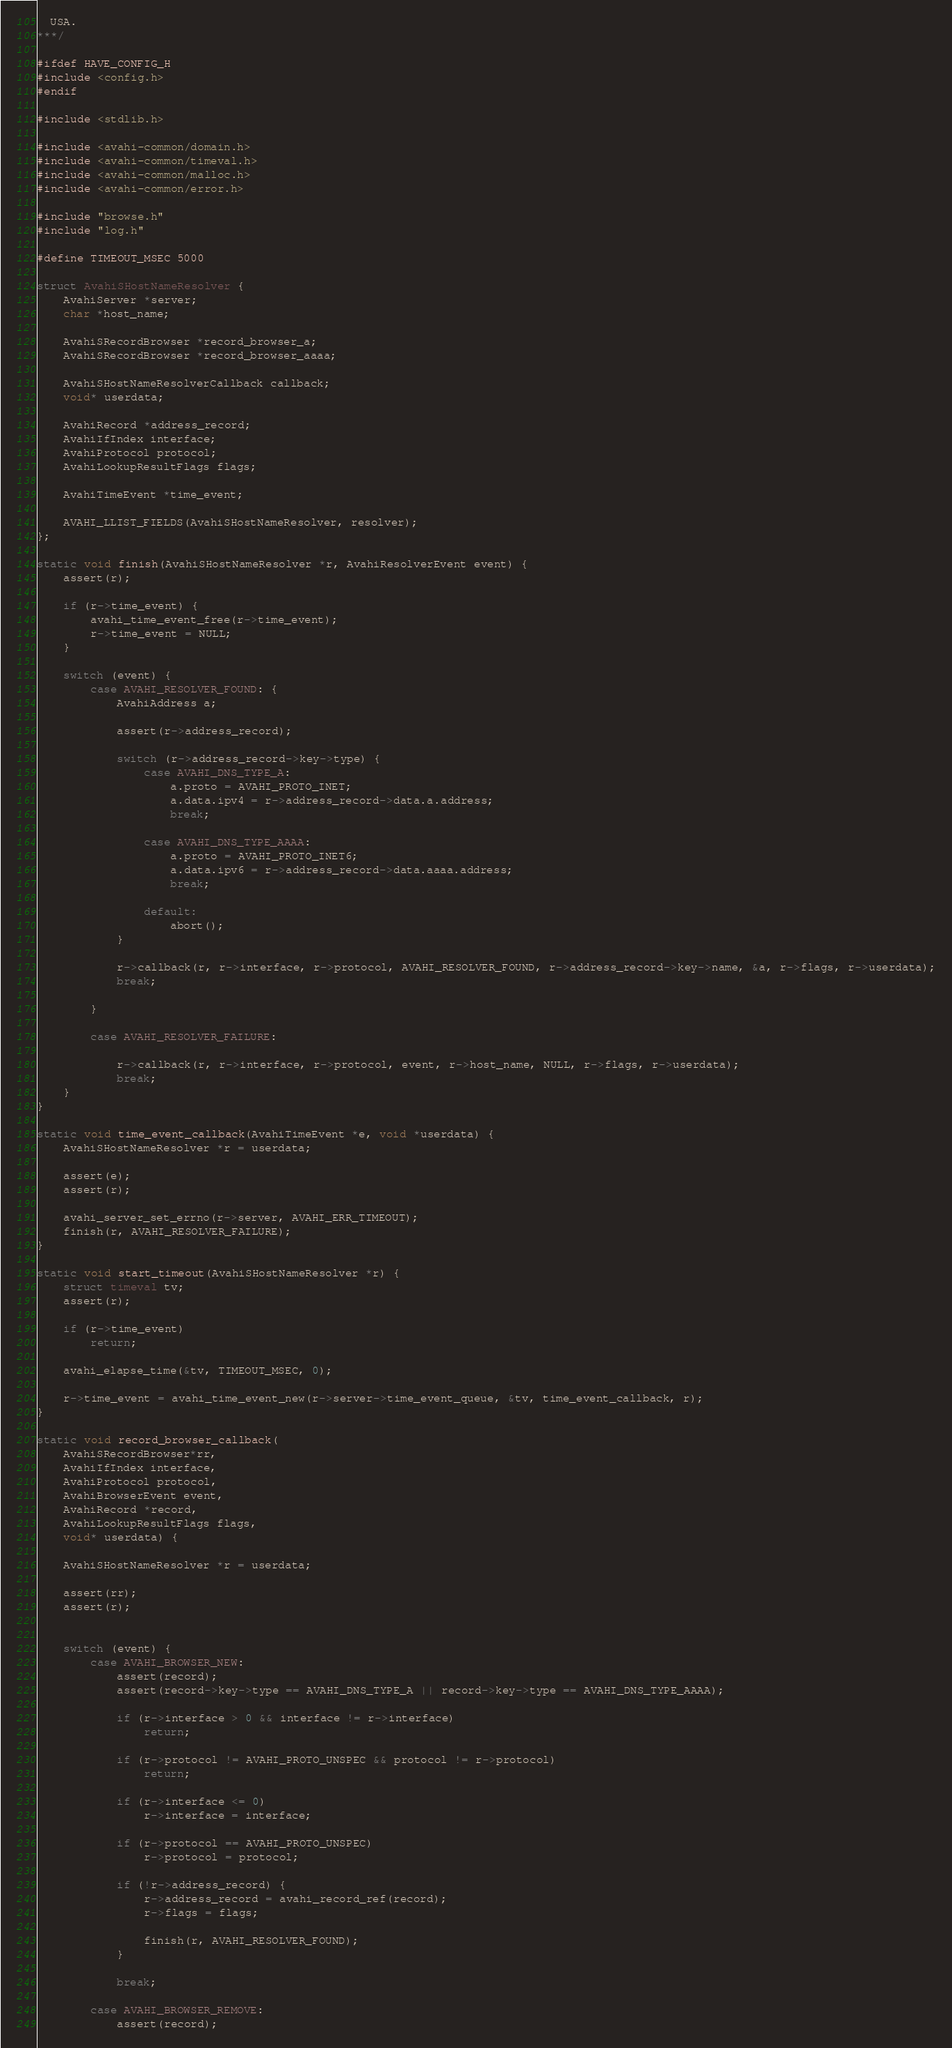<code> <loc_0><loc_0><loc_500><loc_500><_C_>  USA.
***/

#ifdef HAVE_CONFIG_H
#include <config.h>
#endif

#include <stdlib.h>

#include <avahi-common/domain.h>
#include <avahi-common/timeval.h>
#include <avahi-common/malloc.h>
#include <avahi-common/error.h>

#include "browse.h"
#include "log.h"

#define TIMEOUT_MSEC 5000

struct AvahiSHostNameResolver {
    AvahiServer *server;
    char *host_name;

    AvahiSRecordBrowser *record_browser_a;
    AvahiSRecordBrowser *record_browser_aaaa;

    AvahiSHostNameResolverCallback callback;
    void* userdata;

    AvahiRecord *address_record;
    AvahiIfIndex interface;
    AvahiProtocol protocol;
    AvahiLookupResultFlags flags;

    AvahiTimeEvent *time_event;

    AVAHI_LLIST_FIELDS(AvahiSHostNameResolver, resolver);
};

static void finish(AvahiSHostNameResolver *r, AvahiResolverEvent event) {
    assert(r);

    if (r->time_event) {
        avahi_time_event_free(r->time_event);
        r->time_event = NULL;
    }

    switch (event) {
        case AVAHI_RESOLVER_FOUND: {
            AvahiAddress a;

            assert(r->address_record);

            switch (r->address_record->key->type) {
                case AVAHI_DNS_TYPE_A:
                    a.proto = AVAHI_PROTO_INET;
                    a.data.ipv4 = r->address_record->data.a.address;
                    break;

                case AVAHI_DNS_TYPE_AAAA:
                    a.proto = AVAHI_PROTO_INET6;
                    a.data.ipv6 = r->address_record->data.aaaa.address;
                    break;

                default:
                    abort();
            }

            r->callback(r, r->interface, r->protocol, AVAHI_RESOLVER_FOUND, r->address_record->key->name, &a, r->flags, r->userdata);
            break;

        }

        case AVAHI_RESOLVER_FAILURE:

            r->callback(r, r->interface, r->protocol, event, r->host_name, NULL, r->flags, r->userdata);
            break;
    }
}

static void time_event_callback(AvahiTimeEvent *e, void *userdata) {
    AvahiSHostNameResolver *r = userdata;

    assert(e);
    assert(r);

    avahi_server_set_errno(r->server, AVAHI_ERR_TIMEOUT);
    finish(r, AVAHI_RESOLVER_FAILURE);
}

static void start_timeout(AvahiSHostNameResolver *r) {
    struct timeval tv;
    assert(r);

    if (r->time_event)
        return;

    avahi_elapse_time(&tv, TIMEOUT_MSEC, 0);

    r->time_event = avahi_time_event_new(r->server->time_event_queue, &tv, time_event_callback, r);
}

static void record_browser_callback(
    AvahiSRecordBrowser*rr,
    AvahiIfIndex interface,
    AvahiProtocol protocol,
    AvahiBrowserEvent event,
    AvahiRecord *record,
    AvahiLookupResultFlags flags,
    void* userdata) {

    AvahiSHostNameResolver *r = userdata;

    assert(rr);
    assert(r);


    switch (event) {
        case AVAHI_BROWSER_NEW:
            assert(record);
            assert(record->key->type == AVAHI_DNS_TYPE_A || record->key->type == AVAHI_DNS_TYPE_AAAA);

            if (r->interface > 0 && interface != r->interface)
                return;

            if (r->protocol != AVAHI_PROTO_UNSPEC && protocol != r->protocol)
                return;

            if (r->interface <= 0)
                r->interface = interface;

            if (r->protocol == AVAHI_PROTO_UNSPEC)
                r->protocol = protocol;

            if (!r->address_record) {
                r->address_record = avahi_record_ref(record);
                r->flags = flags;

                finish(r, AVAHI_RESOLVER_FOUND);
            }

            break;

        case AVAHI_BROWSER_REMOVE:
            assert(record);</code> 